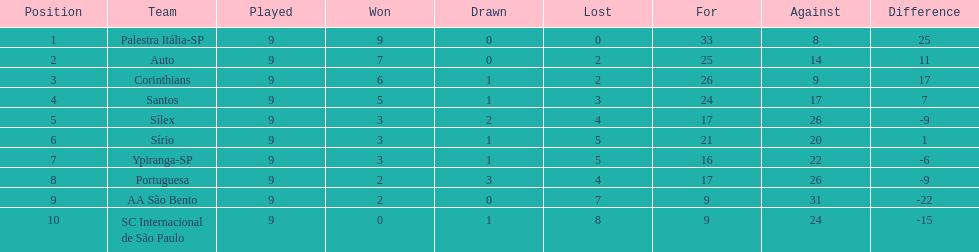Which team was the top scoring team? Palestra Itália-SP. 